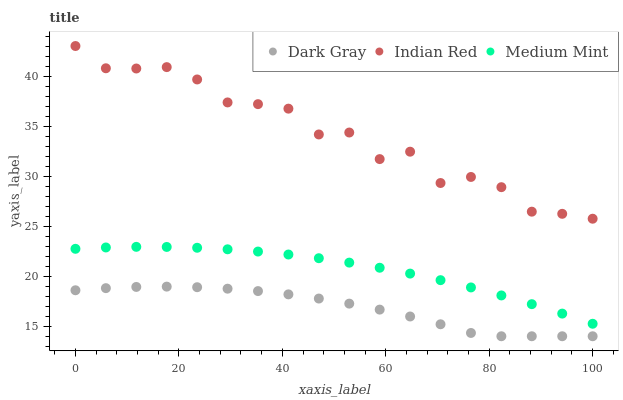Does Dark Gray have the minimum area under the curve?
Answer yes or no. Yes. Does Indian Red have the maximum area under the curve?
Answer yes or no. Yes. Does Medium Mint have the minimum area under the curve?
Answer yes or no. No. Does Medium Mint have the maximum area under the curve?
Answer yes or no. No. Is Medium Mint the smoothest?
Answer yes or no. Yes. Is Indian Red the roughest?
Answer yes or no. Yes. Is Indian Red the smoothest?
Answer yes or no. No. Is Medium Mint the roughest?
Answer yes or no. No. Does Dark Gray have the lowest value?
Answer yes or no. Yes. Does Medium Mint have the lowest value?
Answer yes or no. No. Does Indian Red have the highest value?
Answer yes or no. Yes. Does Medium Mint have the highest value?
Answer yes or no. No. Is Dark Gray less than Medium Mint?
Answer yes or no. Yes. Is Indian Red greater than Medium Mint?
Answer yes or no. Yes. Does Dark Gray intersect Medium Mint?
Answer yes or no. No. 